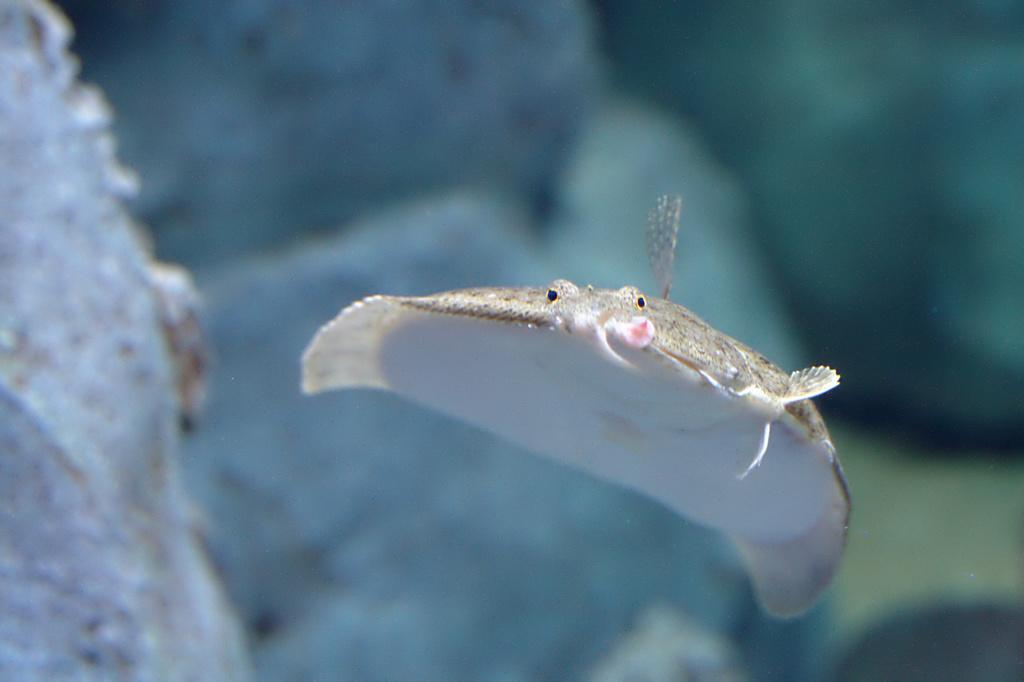What is the main element in the image? There is water in the image. What can be found in the water? There is an aquatic animal in the water. Can you describe the background of the image? The background of the image is blurred. What type of jewel can be seen on the sidewalk in the image? There is no sidewalk or jewel present in the image; it features water with an aquatic animal and a blurred background. 